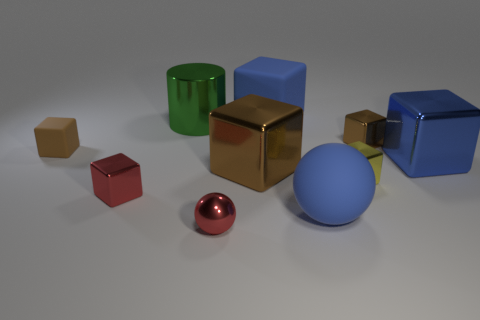Subtract all big blocks. How many blocks are left? 4 Subtract all red spheres. How many spheres are left? 1 Subtract 2 cubes. How many cubes are left? 5 Subtract all blocks. How many objects are left? 3 Subtract all tiny brown rubber cubes. Subtract all small objects. How many objects are left? 4 Add 5 large green cylinders. How many large green cylinders are left? 6 Add 8 large rubber objects. How many large rubber objects exist? 10 Subtract 1 brown cubes. How many objects are left? 9 Subtract all red spheres. Subtract all purple cylinders. How many spheres are left? 1 Subtract all gray cylinders. How many cyan blocks are left? 0 